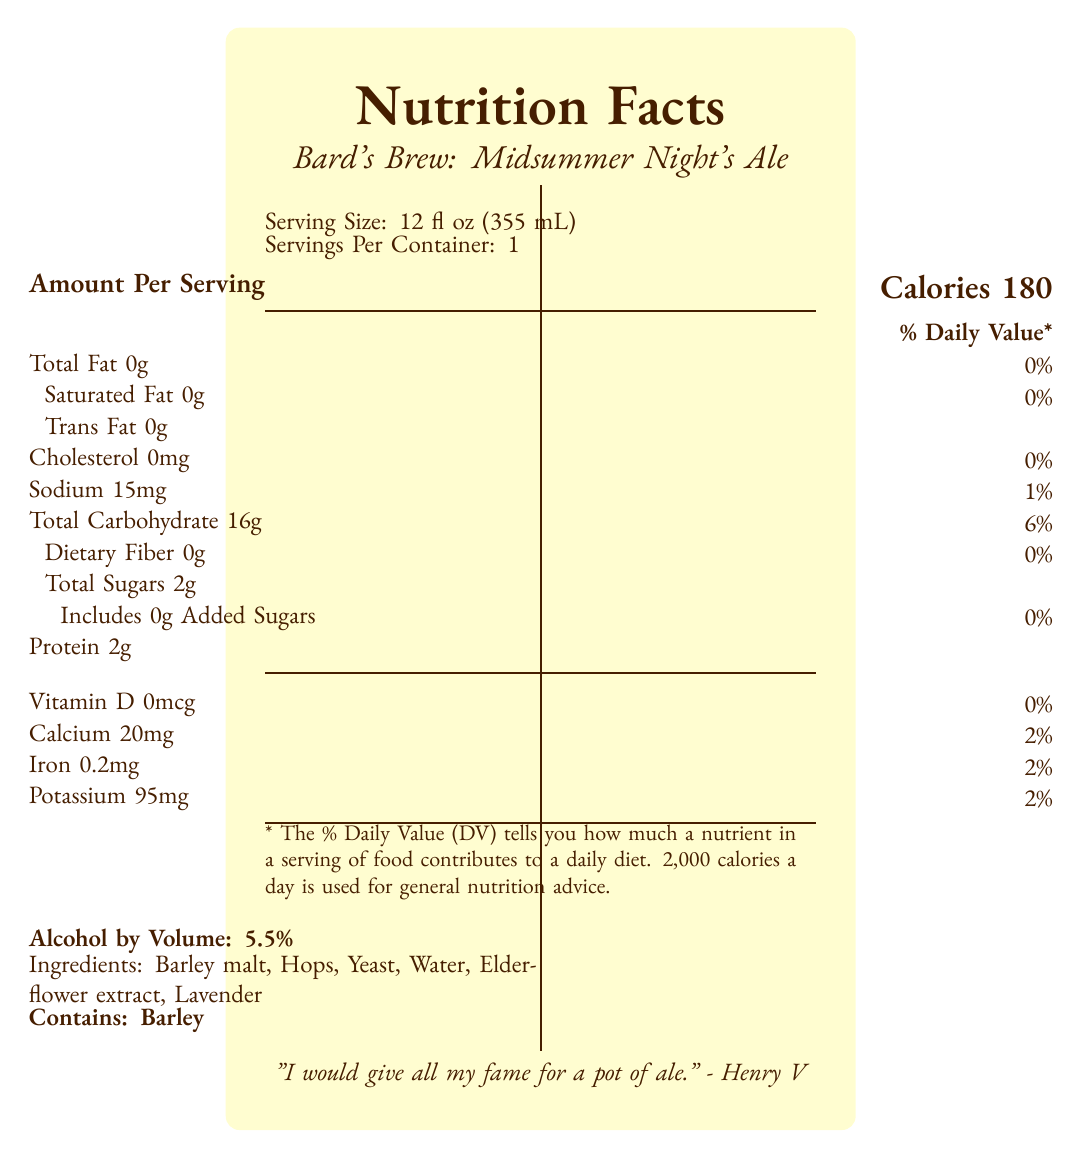what is the serving size for Bard's Brew: Midsummer Night's Ale? The document specifies the serving size as "12 fl oz (355 mL)".
Answer: 12 fl oz (355 mL) how many calories are in one serving of Bard's Brew: Midsummer Night's Ale? The document lists the calories as "Calories 180" in the section "Amount Per Serving".
Answer: 180 calories what is the total carbohydrate content per serving? In the section detailing nutrient content, "Total Carbohydrate" is listed as "16g".
Answer: 16g does Bard's Brew contain any added sugars? The document specifies "Includes 0g Added Sugars" under the "Total Sugars" section.
Answer: No what percentage of the daily value for sodium does one serving provide? The document indicates that "Sodium 15mg" corresponds to "1%" of the daily value.
Answer: 1% what are the main ingredients in Bard's Brew: Midsummer Night's Ale? The ingredients are listed as "Barley malt, Hops, Yeast, Water, Elderflower extract, Lavender".
Answer: Barley malt, Hops, Yeast, Water, Elderflower extract, Lavender what company brews Bard's Brew? The brewery name is listed as "The Globe Brewing Company".
Answer: The Globe Brewing Company with what food items is Bard's Brew recommended to be paired? The food pairings listed are "Aged cheddar, Roasted venison, Rosemary focaccia".
Answer: Aged cheddar, Roasted venison, Rosemary focaccia what is the alcohol by volume (ABV) for Bard's Brew? a. 4.8% b. 5.0% c. 5.5% d. 6.0% The document states "Alcohol by Volume: 5.5%".
Answer: c. 5.5% which nutrient is present in the highest amount? a. Calcium b. Iron c. Potassium d. Sodium Potassium is listed as 95mg, which is the highest among the listed nutrients.
Answer: c. Potassium does Bard's Brew contain any common allergens? The document states "Contains: Barley", indicating it contains barley, which can be an allergen.
Answer: Yes is Bard's Brew suitable for someone on a gluten-free diet? The document does not explicitly state whether Bard's Brew is gluten-free, and barley usually contains gluten.
Answer: Not enough information summarize the main information given in the document. The summary covers the product name, brewing company, purpose, nutritional information, ingredients, recommended food pairings, sustainability note, and distribution.
Answer: Bard's Brew: Midsummer Night's Ale is a limited edition craft beer brewed by The Globe Brewing Company to celebrate the 400th anniversary of Shakespeare's First Folio. It has a serving size of 12 fl oz (355 mL) with one serving per container, providing 180 calories. The beer contains 5.5% alcohol by volume and is made with barley malt, hops, yeast, water, elderflower extract, and lavender. It is recommended to be paired with aged cheddar, roasted venison, and rosemary focaccia. The label also highlights its nutrition contents, including total fat, carbohydrates, protein, and various vitamins and minerals. It is brewed using 100% renewable energy and is available only at select theaters and bookshops nationwide. what is the manufacturing process used for Bard's Brew? The document states that Bard's Brew is "Small-batch crafted using traditional English ale methods with a modern twist".
Answer: Small-batch crafted using traditional English ale methods with a modern twist 